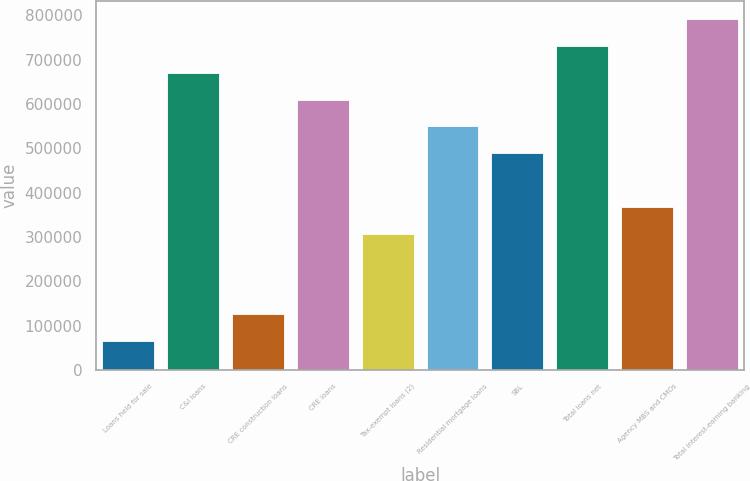Convert chart to OTSL. <chart><loc_0><loc_0><loc_500><loc_500><bar_chart><fcel>Loans held for sale<fcel>C&I loans<fcel>CRE construction loans<fcel>CRE loans<fcel>Tax-exempt loans (2)<fcel>Residential mortgage loans<fcel>SBL<fcel>Total loans net<fcel>Agency MBS and CMOs<fcel>Total interest-earning banking<nl><fcel>64889.6<fcel>670536<fcel>125454<fcel>609971<fcel>307148<fcel>549406<fcel>488842<fcel>731100<fcel>367713<fcel>791665<nl></chart> 